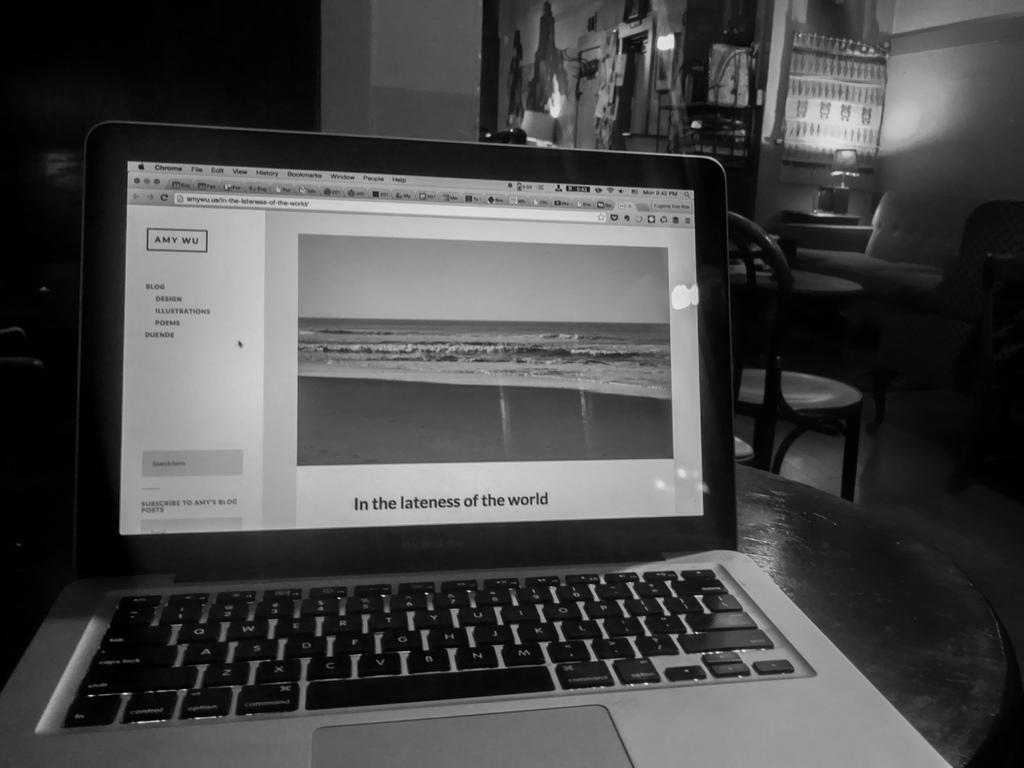<image>
Give a short and clear explanation of the subsequent image. a laptop with 'in the lateness of the world' on the screen 